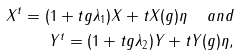Convert formula to latex. <formula><loc_0><loc_0><loc_500><loc_500>X ^ { t } = ( 1 + t g \lambda _ { 1 } ) X + t X ( g ) \eta \ \ a n d \\ Y ^ { t } = ( 1 + t g \lambda _ { 2 } ) Y + t Y ( g ) \eta ,</formula> 